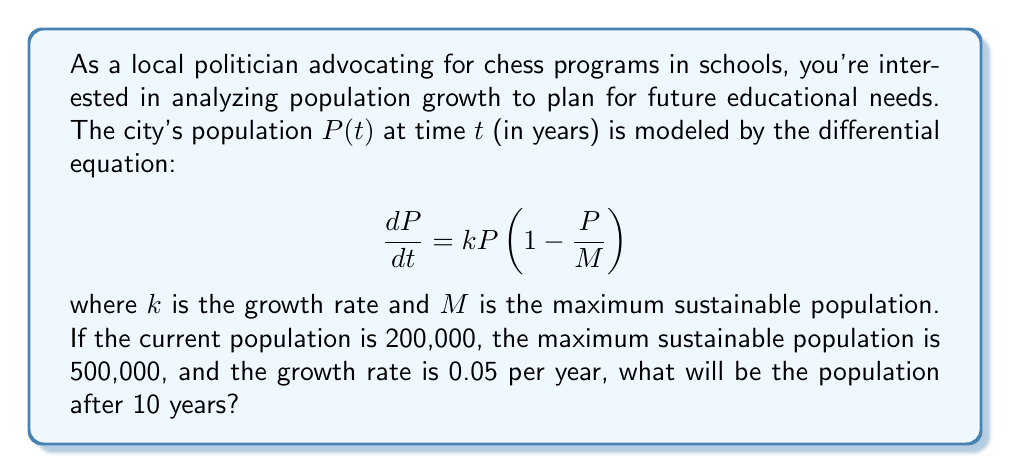Could you help me with this problem? To solve this problem, we need to use the logistic growth model, which is described by the given differential equation. Let's approach this step-by-step:

1) The differential equation is:

   $$\frac{dP}{dt} = kP(1 - \frac{P}{M})$$

2) We're given:
   - Initial population $P(0) = 200,000$
   - Maximum sustainable population $M = 500,000$
   - Growth rate $k = 0.05$ per year
   - We need to find $P(10)$

3) The solution to this logistic differential equation is:

   $$P(t) = \frac{MP_0}{P_0 + (M-P_0)e^{-kt}}$$

   where $P_0$ is the initial population.

4) Substituting our values:

   $$P(t) = \frac{500,000 \cdot 200,000}{200,000 + (500,000-200,000)e^{-0.05t}}$$

5) Simplify:

   $$P(t) = \frac{100,000,000,000}{200,000 + 300,000e^{-0.05t}}$$

6) Now, we want to find $P(10)$, so let's substitute $t=10$:

   $$P(10) = \frac{100,000,000,000}{200,000 + 300,000e^{-0.5}}$$

7) Calculate $e^{-0.5} \approx 0.6065$:

   $$P(10) = \frac{100,000,000,000}{200,000 + 300,000(0.6065)}$$

8) Simplify:

   $$P(10) = \frac{100,000,000,000}{381,950} \approx 261,814$$

Therefore, after 10 years, the population will be approximately 261,814 people.
Answer: The population after 10 years will be approximately 261,814 people. 